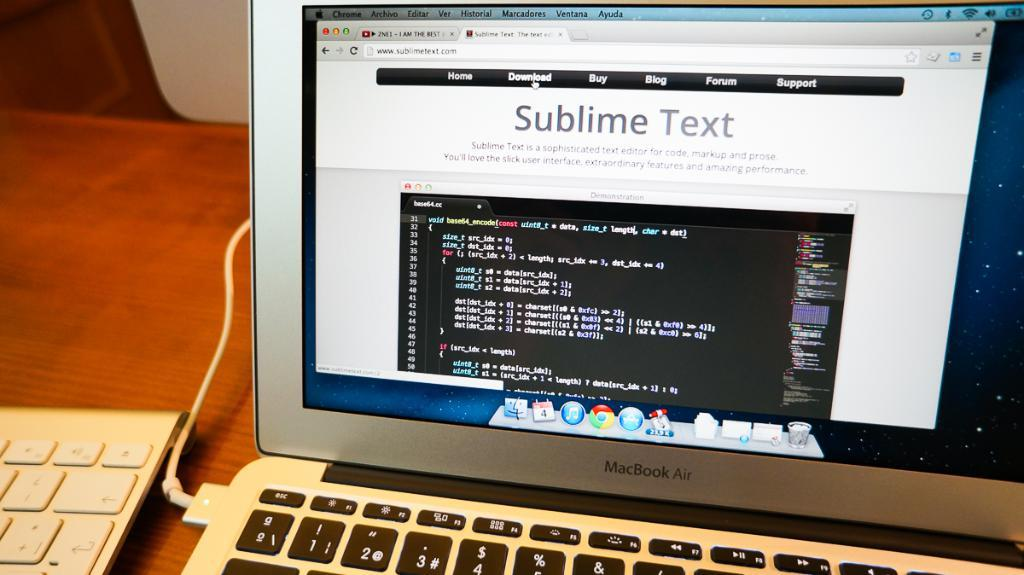Provide a one-sentence caption for the provided image. A computer monitor sitting on a desk displaying Sublime Text page. 